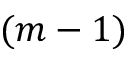Convert formula to latex. <formula><loc_0><loc_0><loc_500><loc_500>( m - 1 )</formula> 